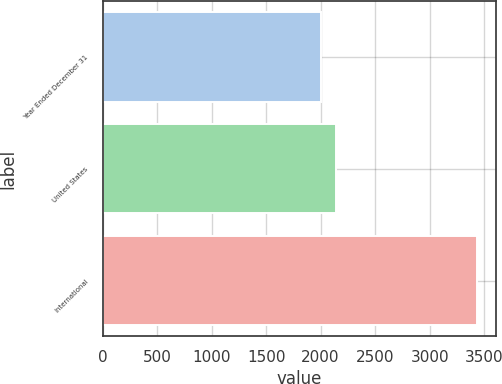Convert chart. <chart><loc_0><loc_0><loc_500><loc_500><bar_chart><fcel>Year Ended December 31<fcel>United States<fcel>International<nl><fcel>2002<fcel>2145.5<fcel>3437<nl></chart> 